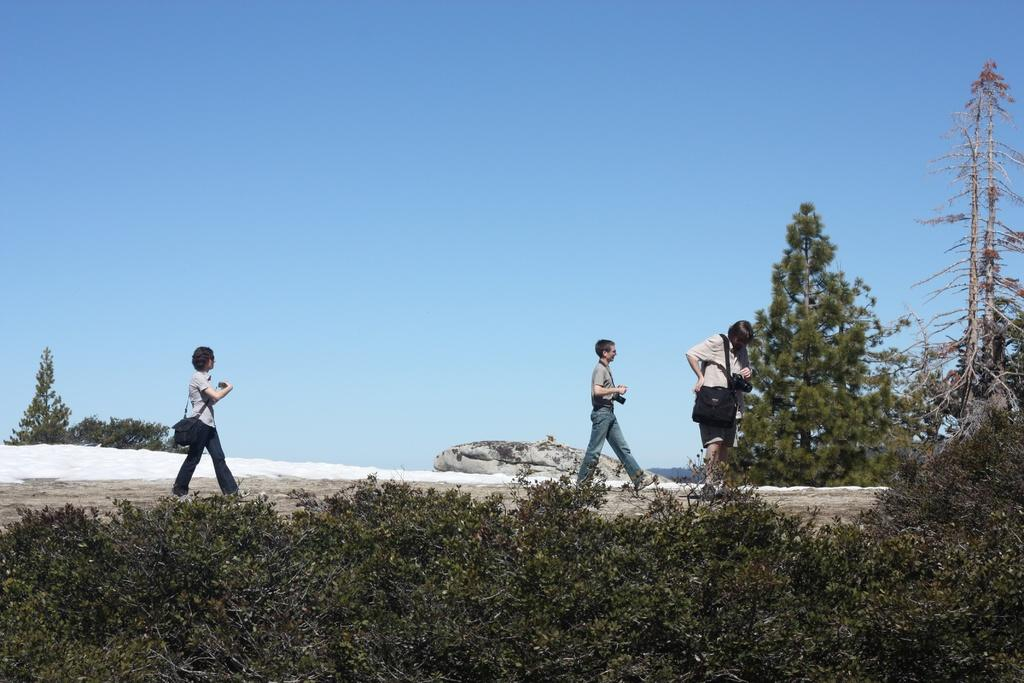How many people are walking in the image? There are three members walking in the image. What type of surface are the members walking on? The members are walking on the land. What can be seen at the bottom of the image? There are plants visible at the bottom of the image. What is visible in the background of the image? There are trees and the sky visible in the background of the image. What type of cakes are the members carrying in the image? There are no cakes visible in the image; the members are not carrying anything. 